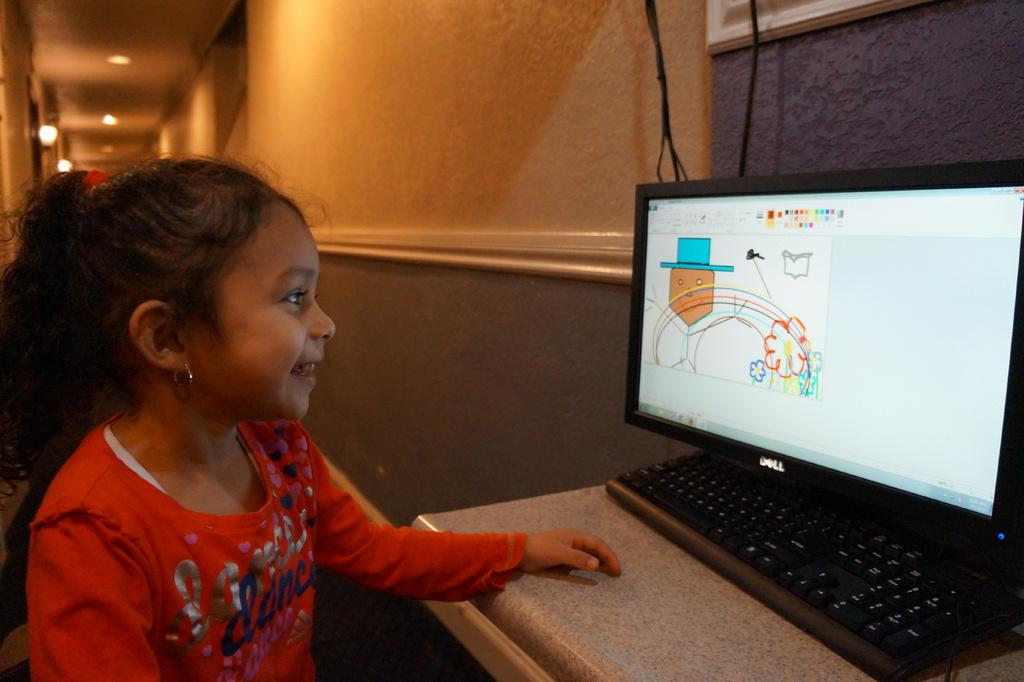<image>
Share a concise interpretation of the image provided. A girl drawing a picture on a computer screen, wearing a shirt with the word dance on it. 